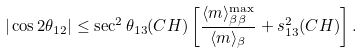Convert formula to latex. <formula><loc_0><loc_0><loc_500><loc_500>| \cos { 2 \theta _ { 1 2 } } | \leq \sec ^ { 2 } { \theta _ { 1 3 } ( C H ) } \left [ \frac { \langle m \rangle _ { \beta \beta } ^ { \max } } { \langle m \rangle _ { \beta } } + s ^ { 2 } _ { 1 3 } ( C H ) \right ] .</formula> 